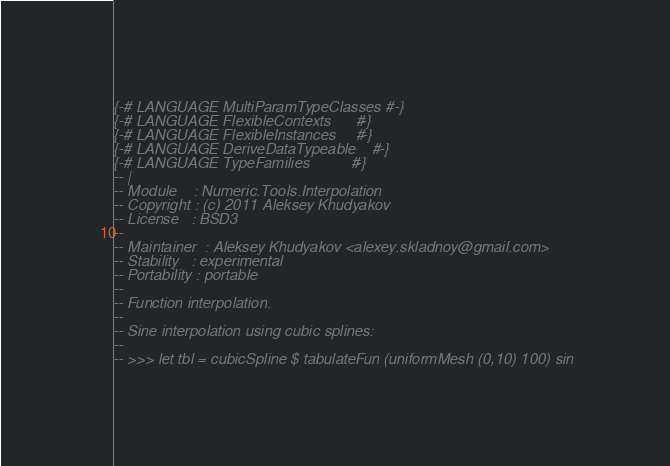<code> <loc_0><loc_0><loc_500><loc_500><_Haskell_>{-# LANGUAGE MultiParamTypeClasses #-}
{-# LANGUAGE FlexibleContexts      #-}
{-# LANGUAGE FlexibleInstances     #-}
{-# LANGUAGE DeriveDataTypeable    #-}
{-# LANGUAGE TypeFamilies          #-}
-- |
-- Module    : Numeric.Tools.Interpolation
-- Copyright : (c) 2011 Aleksey Khudyakov
-- License   : BSD3
--
-- Maintainer  : Aleksey Khudyakov <alexey.skladnoy@gmail.com>
-- Stability   : experimental
-- Portability : portable
--
-- Function interpolation.
--
-- Sine interpolation using cubic splines:
--
-- >>> let tbl = cubicSpline $ tabulateFun (uniformMesh (0,10) 100) sin</code> 